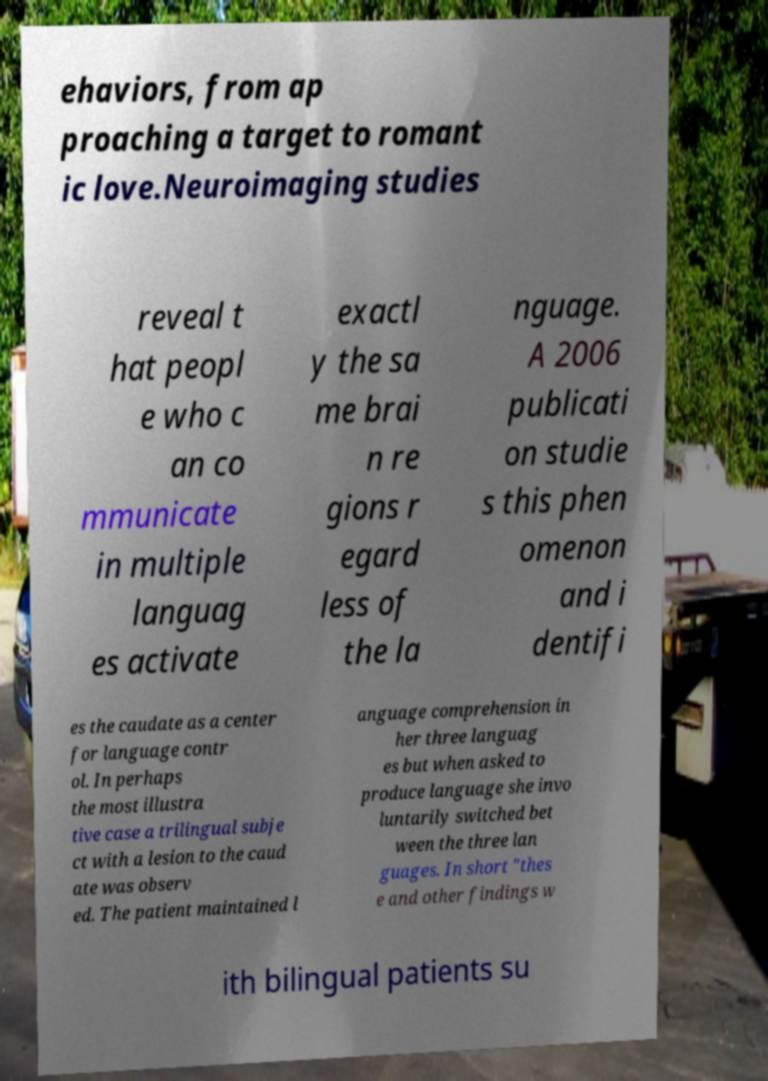Could you extract and type out the text from this image? ehaviors, from ap proaching a target to romant ic love.Neuroimaging studies reveal t hat peopl e who c an co mmunicate in multiple languag es activate exactl y the sa me brai n re gions r egard less of the la nguage. A 2006 publicati on studie s this phen omenon and i dentifi es the caudate as a center for language contr ol. In perhaps the most illustra tive case a trilingual subje ct with a lesion to the caud ate was observ ed. The patient maintained l anguage comprehension in her three languag es but when asked to produce language she invo luntarily switched bet ween the three lan guages. In short "thes e and other findings w ith bilingual patients su 